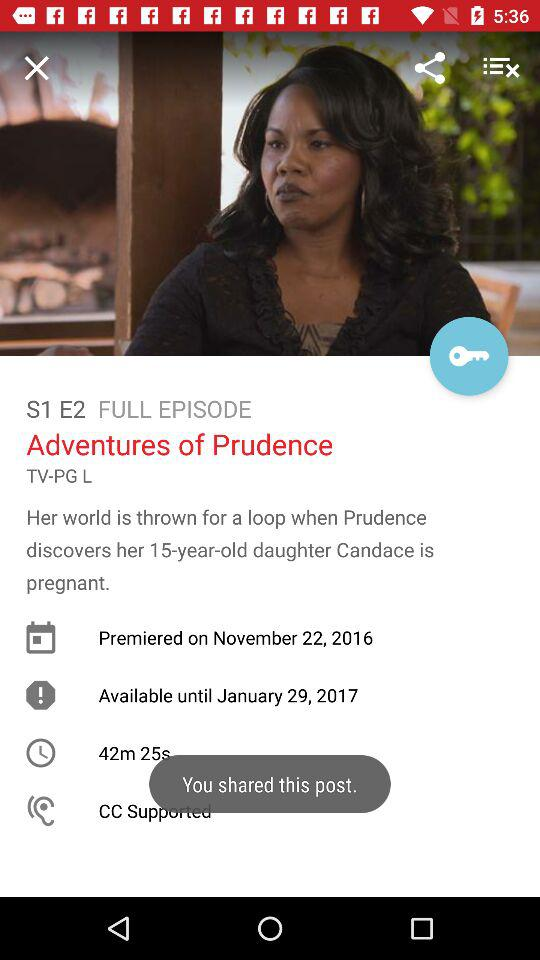How many minutes long is the episode?
Answer the question using a single word or phrase. 42m 25s 